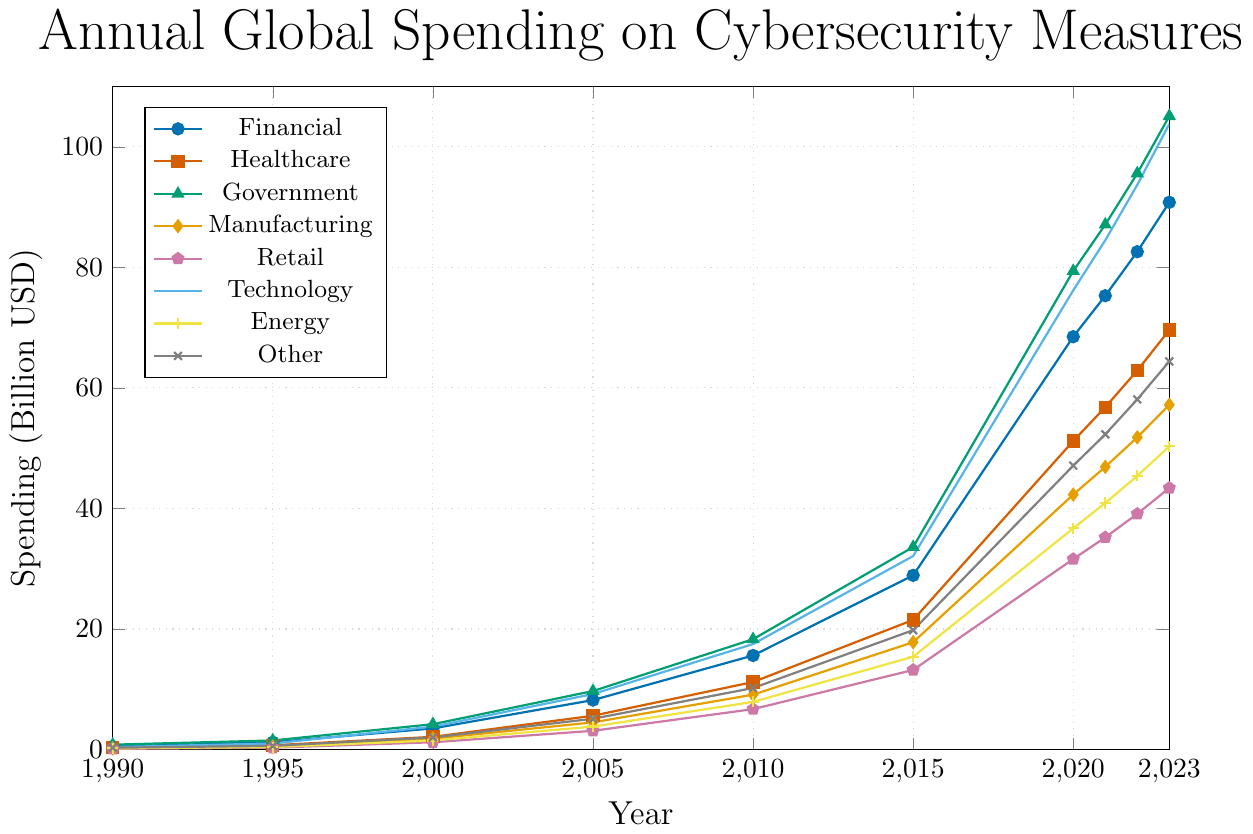What was the spending on cybersecurity for the Financial sector in 2000? By looking at the line representing the Financial sector in 2000, we can read the value on the y-axis directly at the intersection point.
Answer: 3.5 billion USD Which sector had the highest spending on cybersecurity in 2023? By visually comparing the endpoints of all sector lines in 2023, we identify that the Government sector line reaches the highest point.
Answer: Government How much did the Retail sector's spending increase from 1990 to 2023? First, locate the Retail sector's spending in 1990 and 2023 on the y-axis. Subtract the 1990 value (0.1 billion USD) from the 2023 value (43.4 billion USD): 43.4 - 0.1 = 43.3 billion USD.
Answer: 43.3 billion USD Which sectors' spending surpassed 50 billion USD by 2023? By observing the end points of the lines for all sectors in 2023, the lines for Financial, Healthcare, Government, and Technology sectors all surpass the 50 billion USD mark.
Answer: Financial, Healthcare, Government, Technology Between which years did the Technology sector see the largest increase in cybersecurity spending? Identify the years where the slope of the Technology sector line is steepest. The steepest increase appears between 2015 and 2020.
Answer: 2015-2020 What is the average spending on cybersecurity for the Manufacturing sector from 2000 to 2023? Add up the spending values for the Manufacturing sector from 2000 to 2023 (1.8 + 4.5 + 9.1 + 17.8 + 42.3 + 46.9 + 51.8 + 57.2 = 231.4) and divide by the number of years (8). 231.4 / 8 = 28.925 billion USD.
Answer: 28.925 billion USD By how much did the Healthcare sector's spending on cybersecurity increase between 2015 and 2023? Locate the values for Healthcare in 2015 (21.5 billion USD) and 2023 (69.6 billion USD), then subtract: 69.6 - 21.5 = 48.1 billion USD.
Answer: 48.1 billion USD Which sector has the second-lowest spending in 2023, and what is the value? Compare the end points of the lines in 2023 for all sectors. The second-lowest is the Energy sector at around 50.3 billion USD.
Answer: Energy, 50.3 billion USD 